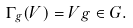<formula> <loc_0><loc_0><loc_500><loc_500>\Gamma _ { g } ( V ) = V g \in G .</formula> 